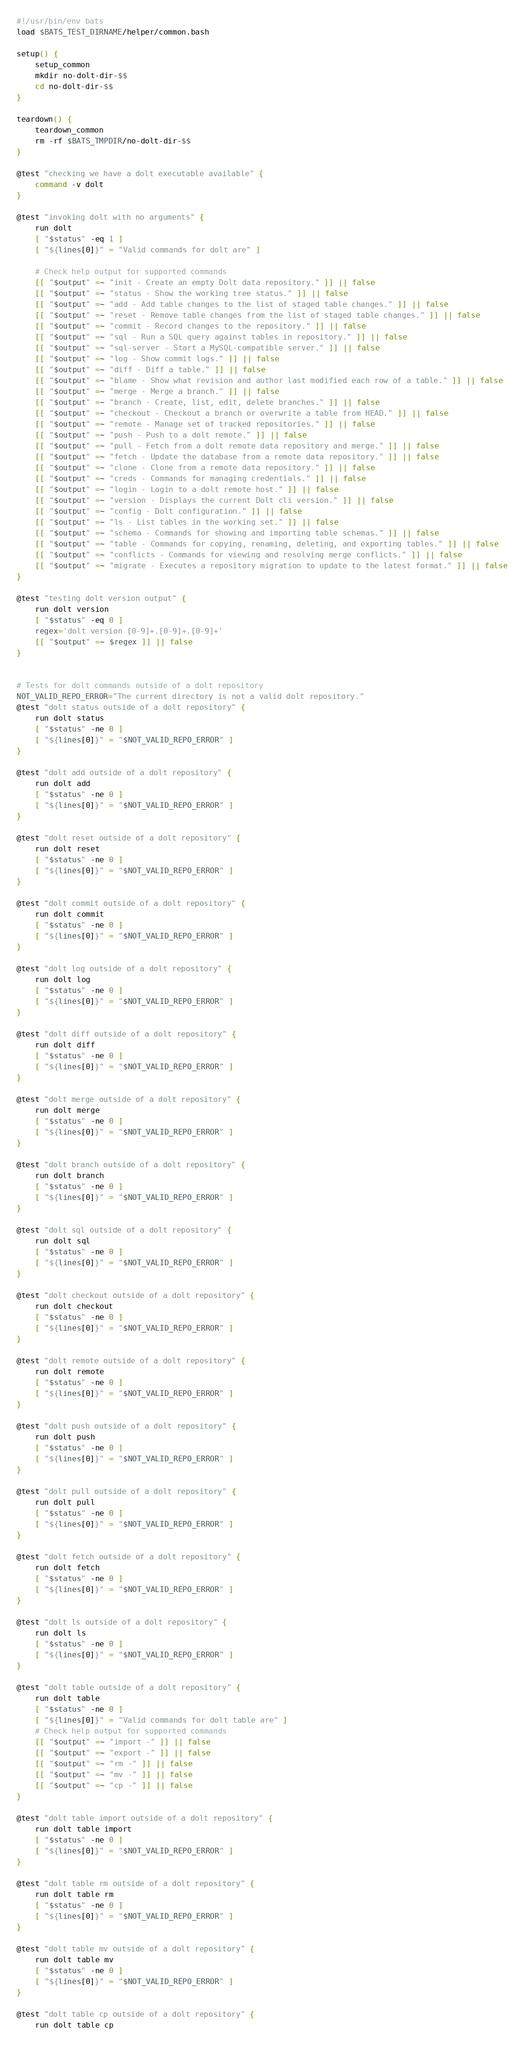Convert code to text. <code><loc_0><loc_0><loc_500><loc_500><_Bash_>#!/usr/bin/env bats
load $BATS_TEST_DIRNAME/helper/common.bash

setup() {
    setup_common
    mkdir no-dolt-dir-$$
    cd no-dolt-dir-$$
}

teardown() {
    teardown_common
    rm -rf $BATS_TMPDIR/no-dolt-dir-$$
}

@test "checking we have a dolt executable available" {
    command -v dolt
}

@test "invoking dolt with no arguments" {
    run dolt
    [ "$status" -eq 1 ]
    [ "${lines[0]}" = "Valid commands for dolt are" ]

    # Check help output for supported commands
    [[ "$output" =~ "init - Create an empty Dolt data repository." ]] || false
    [[ "$output" =~ "status - Show the working tree status." ]] || false
    [[ "$output" =~ "add - Add table changes to the list of staged table changes." ]] || false
    [[ "$output" =~ "reset - Remove table changes from the list of staged table changes." ]] || false
    [[ "$output" =~ "commit - Record changes to the repository." ]] || false
    [[ "$output" =~ "sql - Run a SQL query against tables in repository." ]] || false
    [[ "$output" =~ "sql-server - Start a MySQL-compatible server." ]] || false
    [[ "$output" =~ "log - Show commit logs." ]] || false
    [[ "$output" =~ "diff - Diff a table." ]] || false
    [[ "$output" =~ "blame - Show what revision and author last modified each row of a table." ]] || false
    [[ "$output" =~ "merge - Merge a branch." ]] || false
    [[ "$output" =~ "branch - Create, list, edit, delete branches." ]] || false
    [[ "$output" =~ "checkout - Checkout a branch or overwrite a table from HEAD." ]] || false
    [[ "$output" =~ "remote - Manage set of tracked repositories." ]] || false
    [[ "$output" =~ "push - Push to a dolt remote." ]] || false
    [[ "$output" =~ "pull - Fetch from a dolt remote data repository and merge." ]] || false
    [[ "$output" =~ "fetch - Update the database from a remote data repository." ]] || false
    [[ "$output" =~ "clone - Clone from a remote data repository." ]] || false
    [[ "$output" =~ "creds - Commands for managing credentials." ]] || false
    [[ "$output" =~ "login - Login to a dolt remote host." ]] || false
    [[ "$output" =~ "version - Displays the current Dolt cli version." ]] || false
    [[ "$output" =~ "config - Dolt configuration." ]] || false
    [[ "$output" =~ "ls - List tables in the working set." ]] || false
    [[ "$output" =~ "schema - Commands for showing and importing table schemas." ]] || false
    [[ "$output" =~ "table - Commands for copying, renaming, deleting, and exporting tables." ]] || false
    [[ "$output" =~ "conflicts - Commands for viewing and resolving merge conflicts." ]] || false
    [[ "$output" =~ "migrate - Executes a repository migration to update to the latest format." ]] || false
}

@test "testing dolt version output" {
    run dolt version
    [ "$status" -eq 0 ]
    regex='dolt version [0-9]+.[0-9]+.[0-9]+'
    [[ "$output" =~ $regex ]] || false
}


# Tests for dolt commands outside of a dolt repository
NOT_VALID_REPO_ERROR="The current directory is not a valid dolt repository."
@test "dolt status outside of a dolt repository" {
    run dolt status
    [ "$status" -ne 0 ]
    [ "${lines[0]}" = "$NOT_VALID_REPO_ERROR" ]
}

@test "dolt add outside of a dolt repository" {
    run dolt add
    [ "$status" -ne 0 ]
    [ "${lines[0]}" = "$NOT_VALID_REPO_ERROR" ]
}

@test "dolt reset outside of a dolt repository" {
    run dolt reset
    [ "$status" -ne 0 ]
    [ "${lines[0]}" = "$NOT_VALID_REPO_ERROR" ]
}

@test "dolt commit outside of a dolt repository" {
    run dolt commit
    [ "$status" -ne 0 ]
    [ "${lines[0]}" = "$NOT_VALID_REPO_ERROR" ]
}

@test "dolt log outside of a dolt repository" {
    run dolt log
    [ "$status" -ne 0 ]
    [ "${lines[0]}" = "$NOT_VALID_REPO_ERROR" ]
}

@test "dolt diff outside of a dolt repository" {
    run dolt diff
    [ "$status" -ne 0 ]
    [ "${lines[0]}" = "$NOT_VALID_REPO_ERROR" ]
}

@test "dolt merge outside of a dolt repository" {
    run dolt merge
    [ "$status" -ne 0 ]
    [ "${lines[0]}" = "$NOT_VALID_REPO_ERROR" ]
}

@test "dolt branch outside of a dolt repository" {
    run dolt branch
    [ "$status" -ne 0 ]
    [ "${lines[0]}" = "$NOT_VALID_REPO_ERROR" ]
}

@test "dolt sql outside of a dolt repository" {
    run dolt sql
    [ "$status" -ne 0 ]
    [ "${lines[0]}" = "$NOT_VALID_REPO_ERROR" ]
}

@test "dolt checkout outside of a dolt repository" {
    run dolt checkout
    [ "$status" -ne 0 ]
    [ "${lines[0]}" = "$NOT_VALID_REPO_ERROR" ]
}

@test "dolt remote outside of a dolt repository" {
    run dolt remote
    [ "$status" -ne 0 ]
    [ "${lines[0]}" = "$NOT_VALID_REPO_ERROR" ]
}

@test "dolt push outside of a dolt repository" {
    run dolt push
    [ "$status" -ne 0 ]
    [ "${lines[0]}" = "$NOT_VALID_REPO_ERROR" ]
}

@test "dolt pull outside of a dolt repository" {
    run dolt pull
    [ "$status" -ne 0 ]
    [ "${lines[0]}" = "$NOT_VALID_REPO_ERROR" ]
}

@test "dolt fetch outside of a dolt repository" {
    run dolt fetch
    [ "$status" -ne 0 ]
    [ "${lines[0]}" = "$NOT_VALID_REPO_ERROR" ]
}

@test "dolt ls outside of a dolt repository" {
    run dolt ls
    [ "$status" -ne 0 ]
    [ "${lines[0]}" = "$NOT_VALID_REPO_ERROR" ]
}

@test "dolt table outside of a dolt repository" {
    run dolt table
    [ "$status" -ne 0 ]
    [ "${lines[0]}" = "Valid commands for dolt table are" ]
    # Check help output for supported commands
    [[ "$output" =~ "import -" ]] || false
    [[ "$output" =~ "export -" ]] || false
    [[ "$output" =~ "rm -" ]] || false
    [[ "$output" =~ "mv -" ]] || false
    [[ "$output" =~ "cp -" ]] || false
}

@test "dolt table import outside of a dolt repository" {
    run dolt table import
    [ "$status" -ne 0 ]
    [ "${lines[0]}" = "$NOT_VALID_REPO_ERROR" ]
}

@test "dolt table rm outside of a dolt repository" {
    run dolt table rm
    [ "$status" -ne 0 ]
    [ "${lines[0]}" = "$NOT_VALID_REPO_ERROR" ]
}

@test "dolt table mv outside of a dolt repository" {
    run dolt table mv
    [ "$status" -ne 0 ]
    [ "${lines[0]}" = "$NOT_VALID_REPO_ERROR" ]
}

@test "dolt table cp outside of a dolt repository" {
    run dolt table cp</code> 